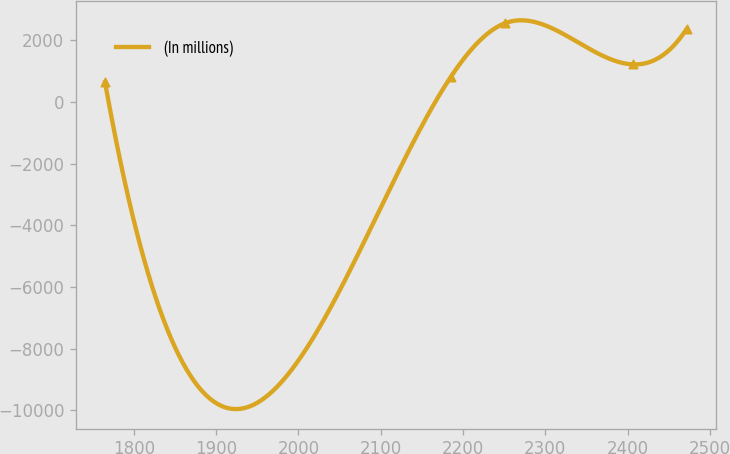<chart> <loc_0><loc_0><loc_500><loc_500><line_chart><ecel><fcel>(In millions)<nl><fcel>1765.07<fcel>636.66<nl><fcel>2185.02<fcel>811.33<nl><fcel>2250.73<fcel>2556.13<nl><fcel>2406.18<fcel>1222.62<nl><fcel>2471.89<fcel>2381.46<nl></chart> 